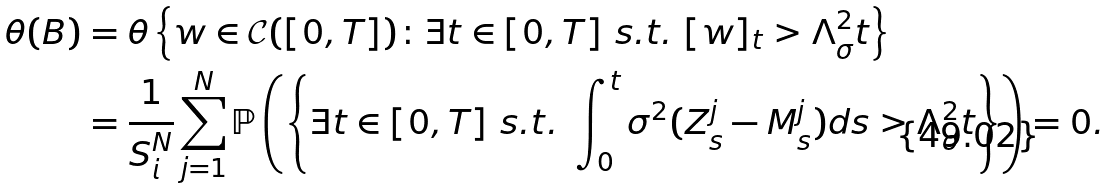Convert formula to latex. <formula><loc_0><loc_0><loc_500><loc_500>\theta ( B ) & = \theta \left \{ w \in \mathcal { C } ( [ 0 , T ] ) \colon \exists t \in [ 0 , T ] \ s . t . \ [ w ] _ { t } > \Lambda ^ { 2 } _ { \sigma } t \right \} \\ & = \frac { 1 } { S _ { i } ^ { N } } \sum _ { j = 1 } ^ { N } \mathbb { P } \left ( \left \{ \exists t \in [ 0 , T ] \ s . t . \ \int _ { 0 } ^ { t } \sigma ^ { 2 } ( Z ^ { j } _ { s } - M ^ { j } _ { s } ) d s > \Lambda ^ { 2 } _ { \sigma } t \right \} \right ) = 0 .</formula> 